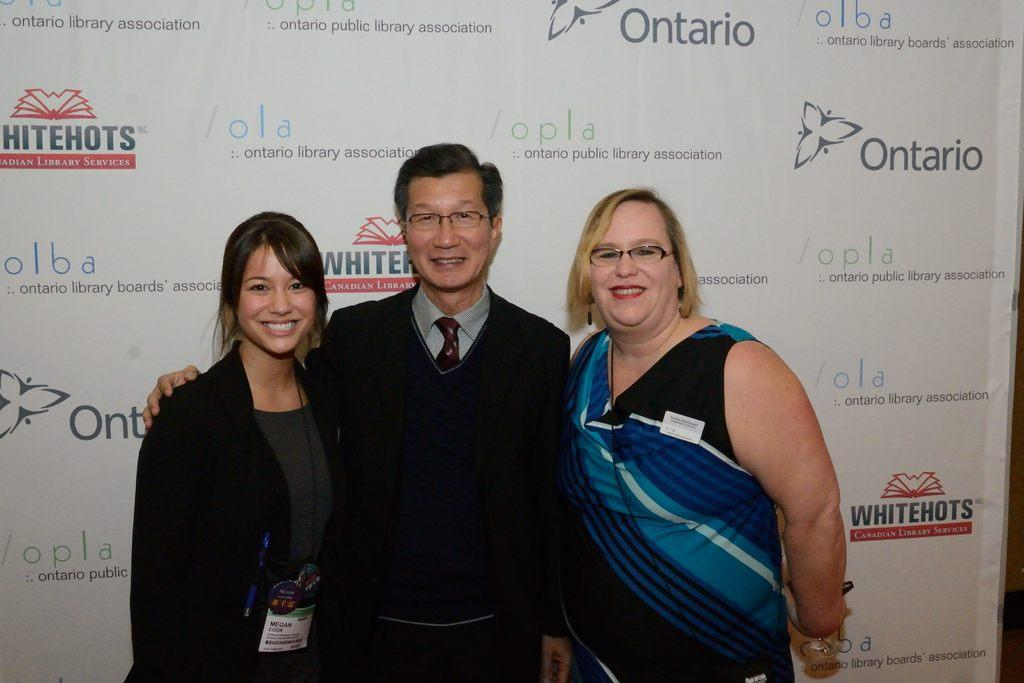<image>
Present a compact description of the photo's key features. the word Ontario is behind some people that are posing 